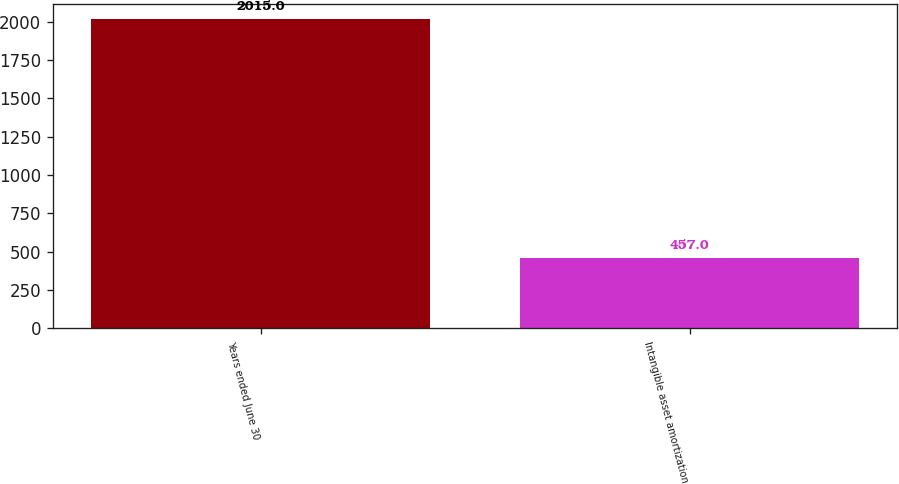<chart> <loc_0><loc_0><loc_500><loc_500><bar_chart><fcel>Years ended June 30<fcel>Intangible asset amortization<nl><fcel>2015<fcel>457<nl></chart> 